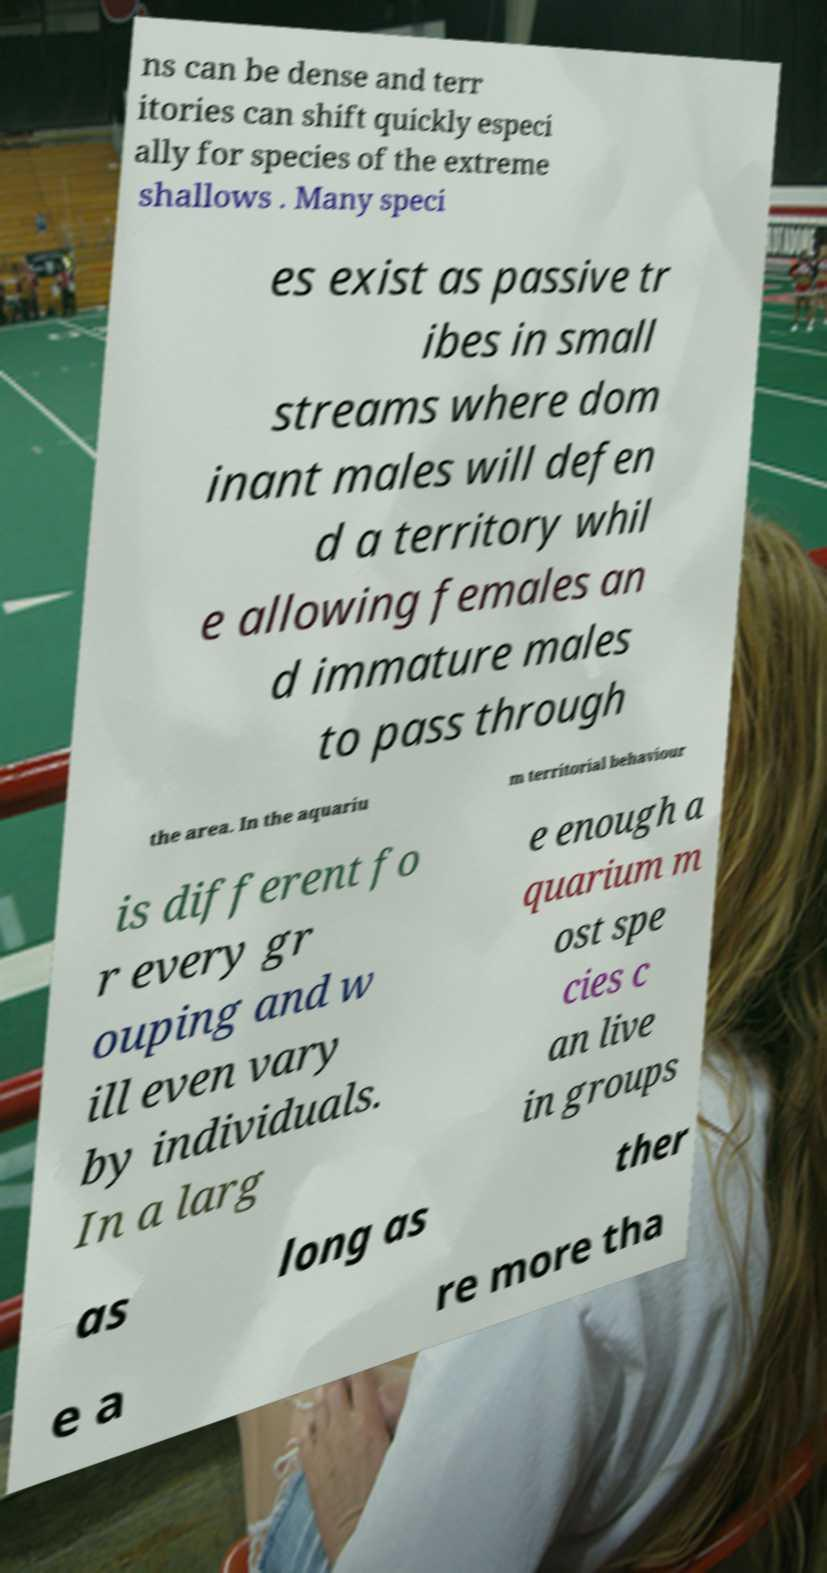Please read and relay the text visible in this image. What does it say? ns can be dense and terr itories can shift quickly especi ally for species of the extreme shallows . Many speci es exist as passive tr ibes in small streams where dom inant males will defen d a territory whil e allowing females an d immature males to pass through the area. In the aquariu m territorial behaviour is different fo r every gr ouping and w ill even vary by individuals. In a larg e enough a quarium m ost spe cies c an live in groups as long as ther e a re more tha 